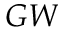<formula> <loc_0><loc_0><loc_500><loc_500>G W</formula> 